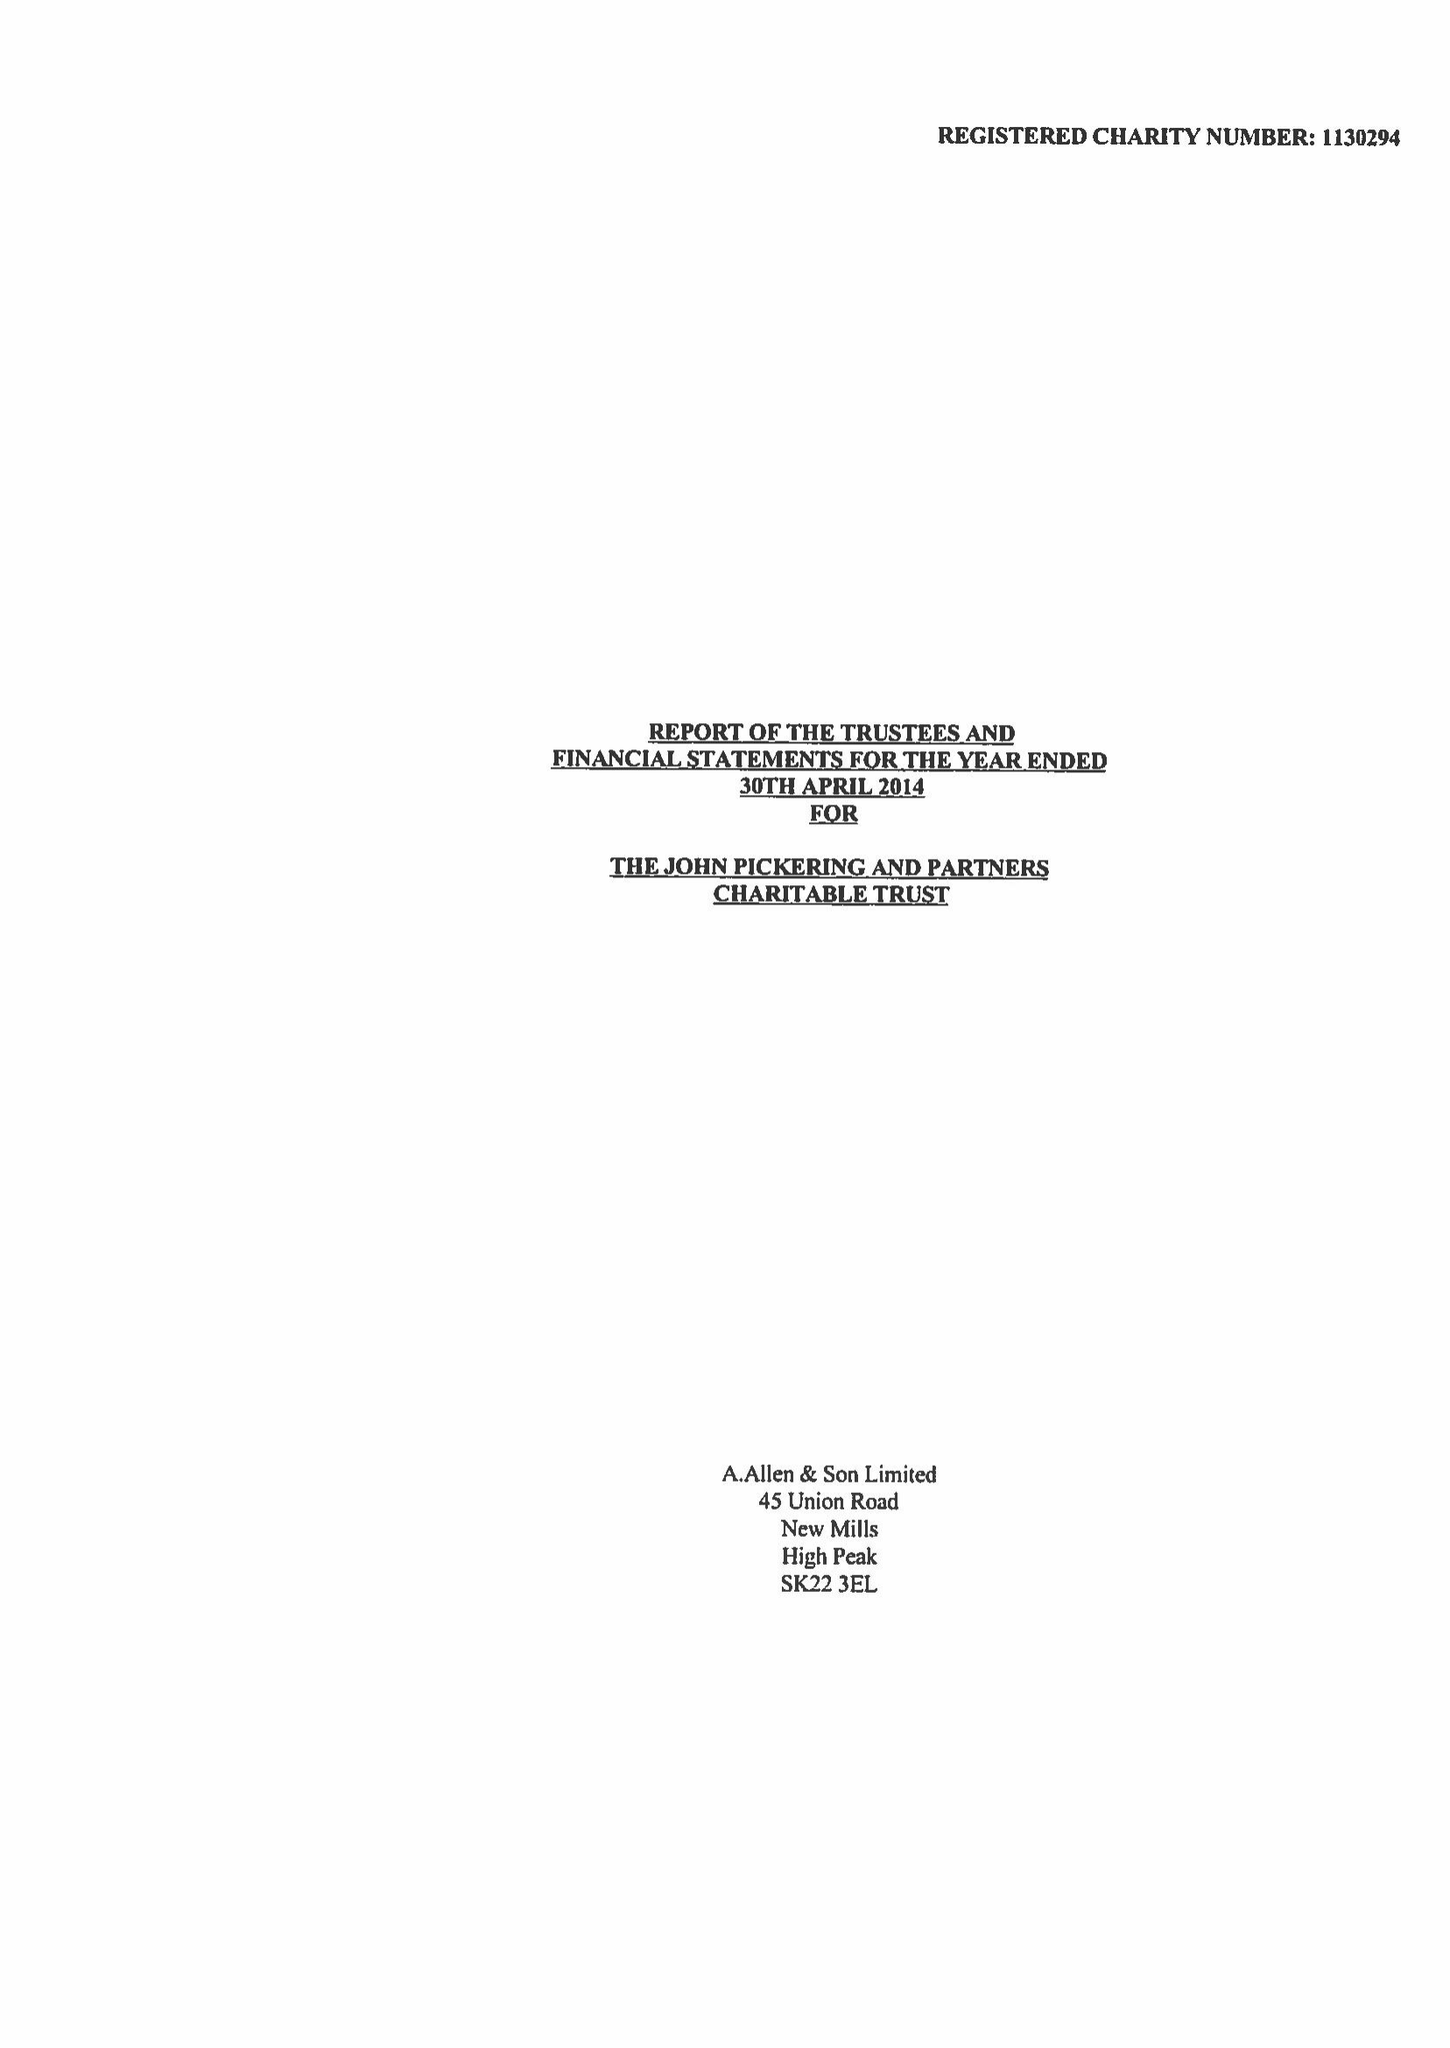What is the value for the address__post_town?
Answer the question using a single word or phrase. HIGH PEAK 